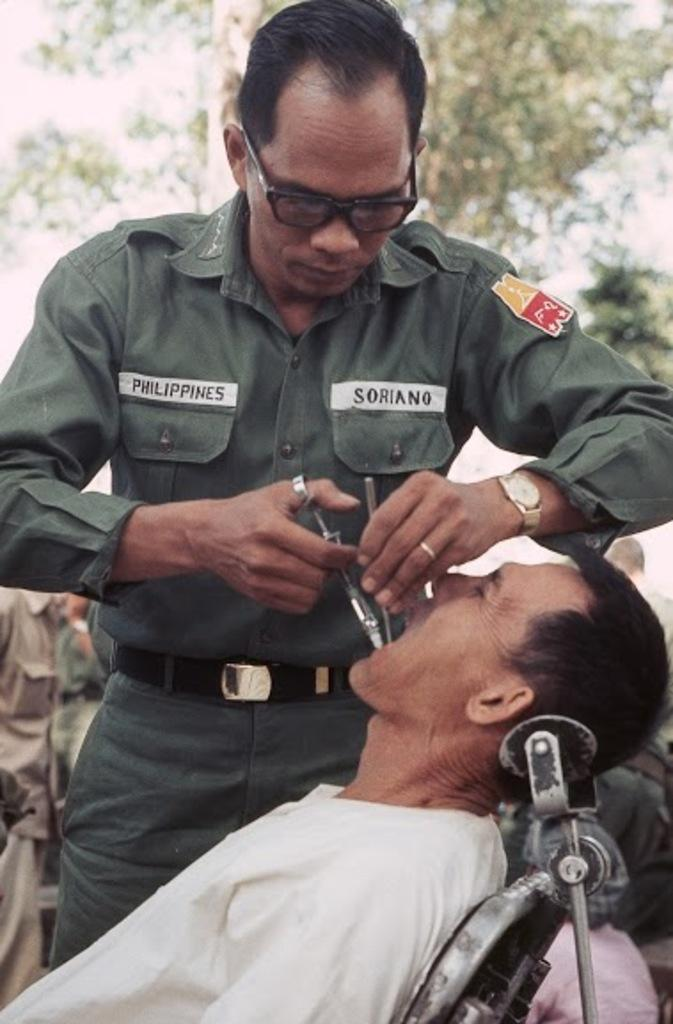What is the man in the image doing? The man is sitting on a chair in the image. What is the other person in the image doing? There is a person standing in the image. What is the standing person holding? The standing person is holding an object. What can be seen in the background of the image? Trees and the sky are visible in the background of the image. What is the taste of the building in the image? There is no building present in the image, so it is not possible to determine its taste. 